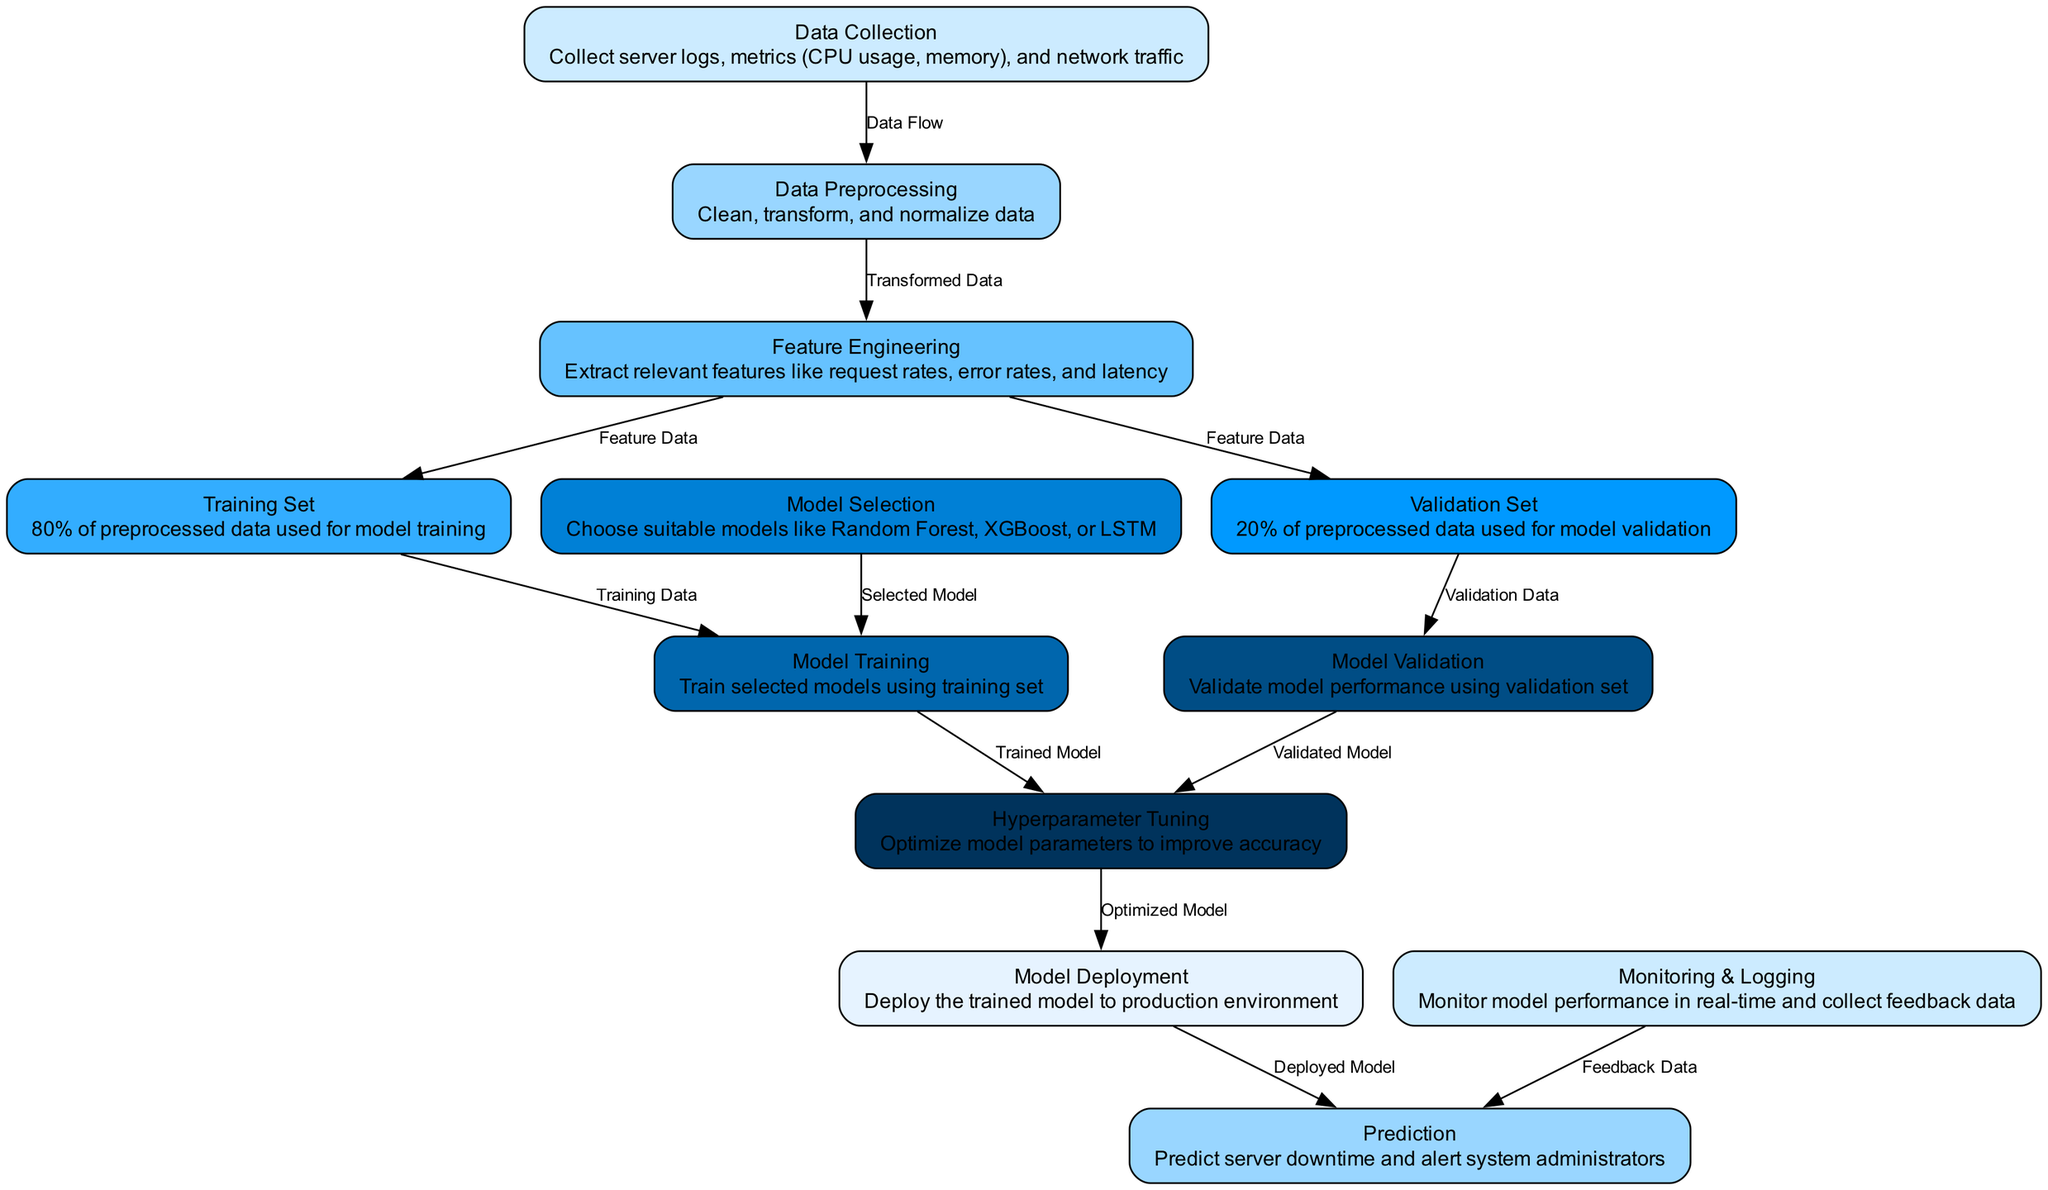What is the first step in the process? The diagram indicates that the first node in the process is "Data Collection," which involves collecting server logs and metrics.
Answer: Data Collection How many nodes are represented in the diagram? By counting the listed nodes in the diagram, there are a total of 12 different steps or components represented.
Answer: 12 What percentage of data is used for training the model? The diagram states that 80% of the preprocessed data is used to create the "Training Set."
Answer: 80% What is the relationship between "Model Training" and "Model Validation"? The edge connecting "Model Training" to "Hyperparameter Tuning" indicates that the model must be trained before it can be validated with the "Validation Set."
Answer: Training before Validation Which models are considered during the "Model Selection" step? The diagram lists examples of models such as Random Forest, XGBoost, and LSTM that can be selected during this step.
Answer: Random Forest, XGBoost, LSTM What action is taken during the "Monitoring & Logging" phase? The diagram specifies that this phase involves monitoring the model's performance in real-time and collecting feedback data for continuous improvement.
Answer: Monitor performance and collect feedback What comes directly after "Hyperparameter Tuning"? According to the diagram, the step that follows "Hyperparameter Tuning" is "Model Deployment," where the optimized model is deployed to the production environment.
Answer: Model Deployment Which node provides feedback data to the "Prediction" node? The "Monitoring & Logging" node is shown to feed back into the "Prediction" node, facilitating ongoing improvements based on performance metrics.
Answer: Monitoring & Logging What is the purpose of "Feature Engineering"? The diagram states that "Feature Engineering" is essential to extract relevant features such as request rates, error rates, and latency from the collected data for modeling.
Answer: Extract relevant features 